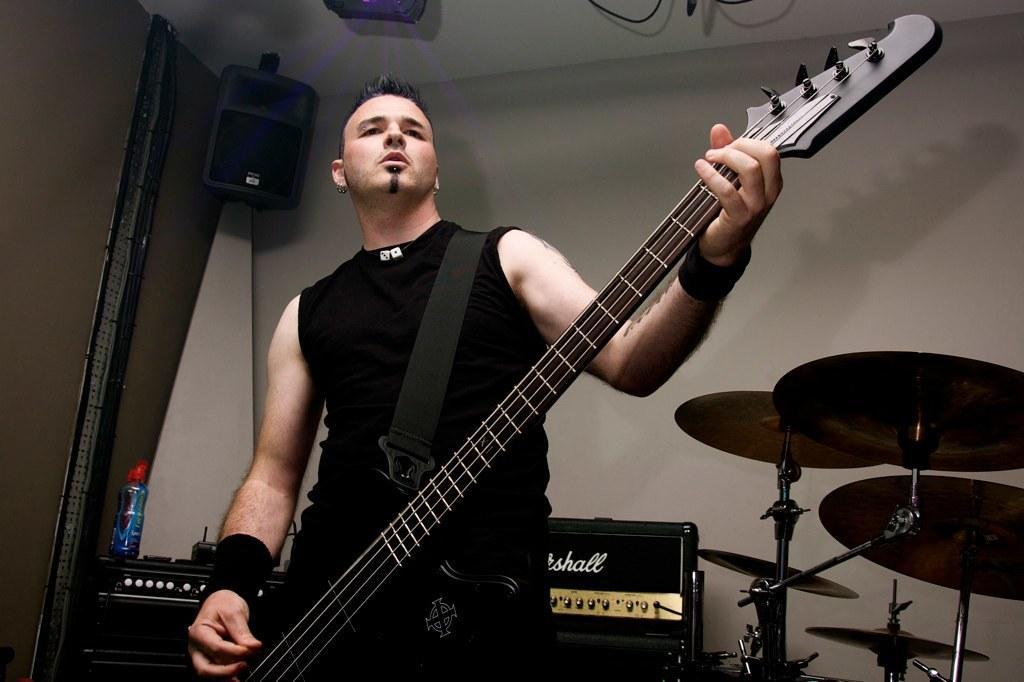Could you give a brief overview of what you see in this image? In this image their is a man standing and holding the guitar with his hand and playing. At the background there are musical plates,amplifier and a speaker. To the left side there is a bottle and a wall. 